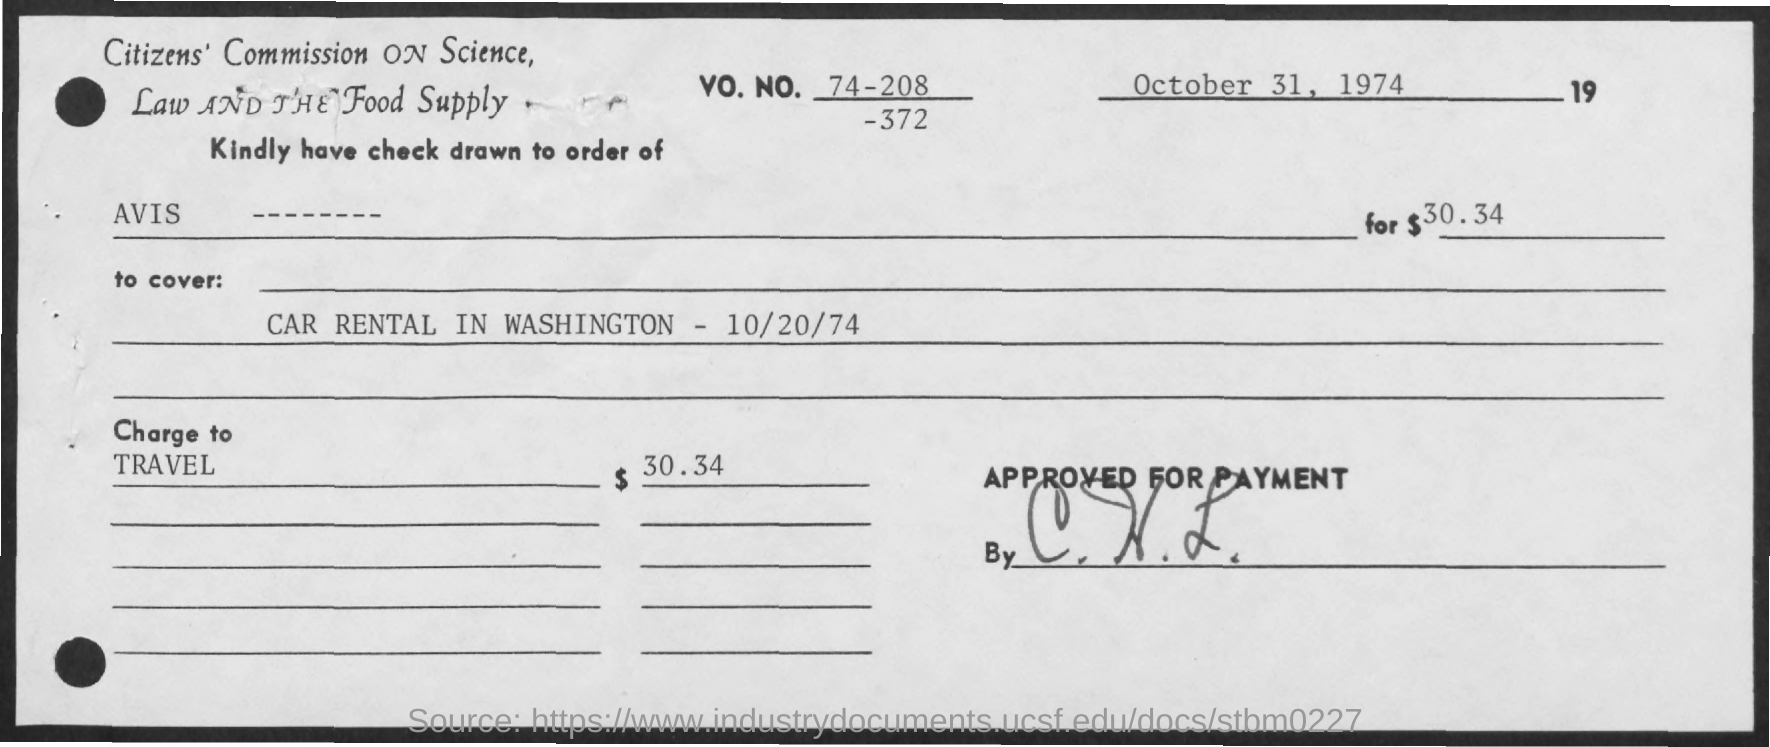Give some essential details in this illustration. The document titled 'Car Rental in Washington - 10/20/74' contains information about car rentals in Washington. The charge to travel is $30.34. 